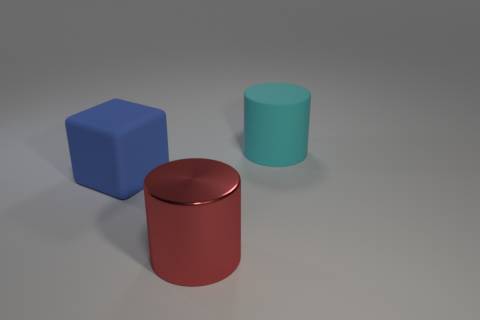Add 1 matte blocks. How many objects exist? 4 Subtract all cylinders. How many objects are left? 1 Subtract all big brown matte cylinders. Subtract all blue objects. How many objects are left? 2 Add 3 blue rubber cubes. How many blue rubber cubes are left? 4 Add 1 large matte cylinders. How many large matte cylinders exist? 2 Subtract 0 brown balls. How many objects are left? 3 